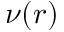Convert formula to latex. <formula><loc_0><loc_0><loc_500><loc_500>\nu ( r )</formula> 